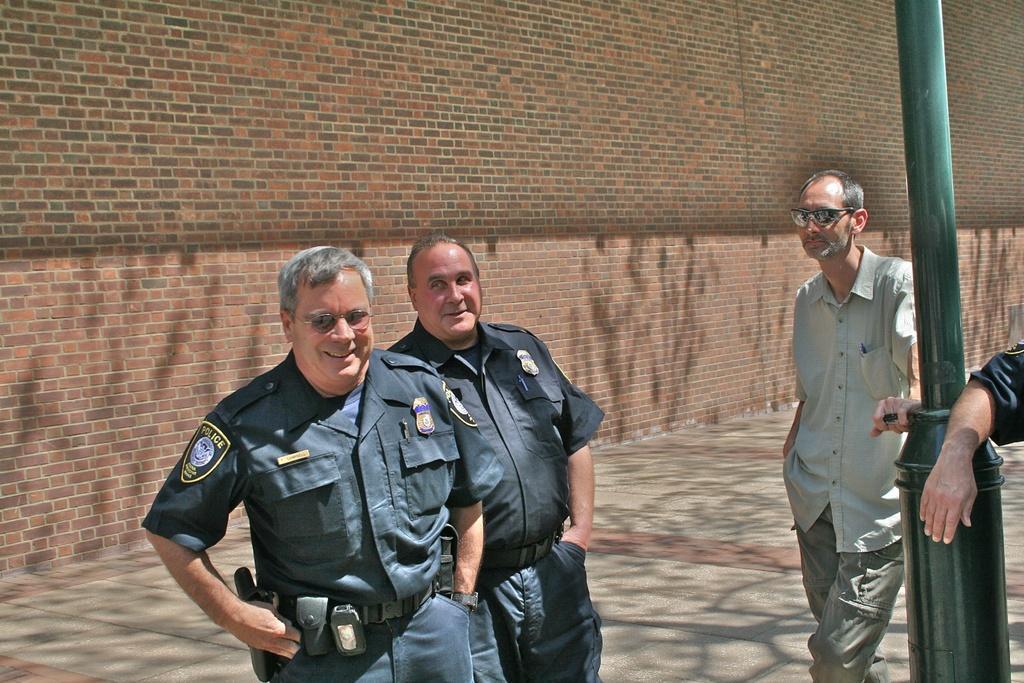Please provide a concise description of this image. In this image I can see two persons wearing uniforms are standing and another person wearing shirt, pant and goggles is standing. I can see a metal pole which is green in color, a person's hand and the sidewalk. In the background I can see the wall which is made of bricks. 